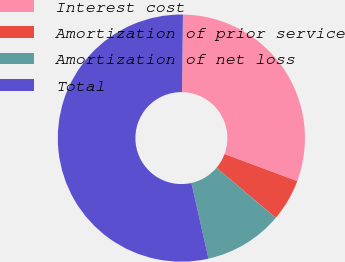Convert chart to OTSL. <chart><loc_0><loc_0><loc_500><loc_500><pie_chart><fcel>Interest cost<fcel>Amortization of prior service<fcel>Amortization of net loss<fcel>Total<nl><fcel>30.46%<fcel>5.5%<fcel>10.32%<fcel>53.72%<nl></chart> 